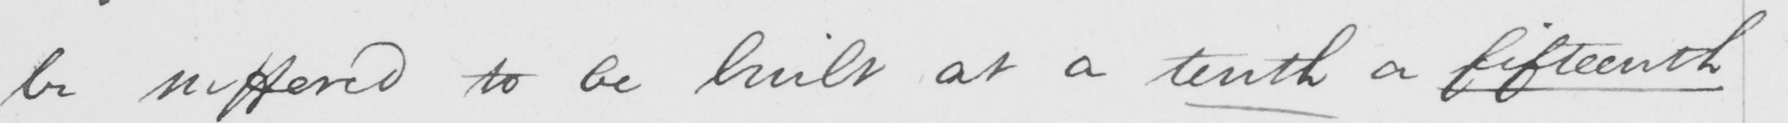Transcribe the text shown in this historical manuscript line. be suffered to be built at a tenth a fifteenth 